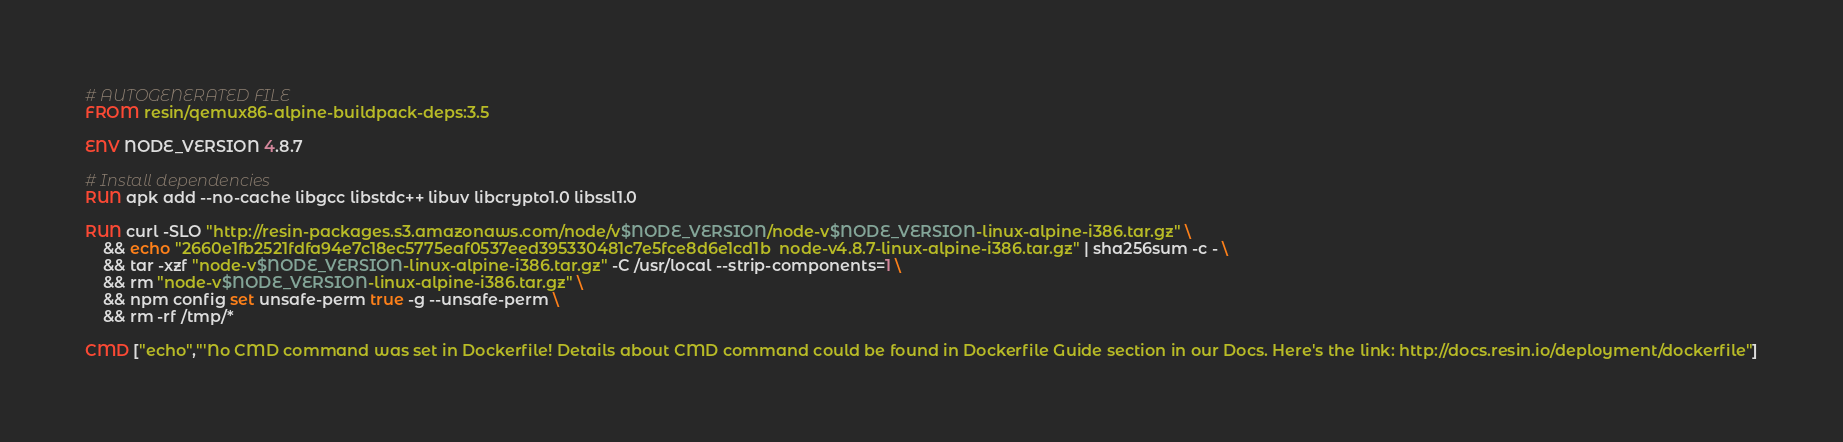<code> <loc_0><loc_0><loc_500><loc_500><_Dockerfile_># AUTOGENERATED FILE
FROM resin/qemux86-alpine-buildpack-deps:3.5

ENV NODE_VERSION 4.8.7

# Install dependencies
RUN apk add --no-cache libgcc libstdc++ libuv libcrypto1.0 libssl1.0

RUN curl -SLO "http://resin-packages.s3.amazonaws.com/node/v$NODE_VERSION/node-v$NODE_VERSION-linux-alpine-i386.tar.gz" \
	&& echo "2660e1fb2521fdfa94e7c18ec5775eaf0537eed395330481c7e5fce8d6e1cd1b  node-v4.8.7-linux-alpine-i386.tar.gz" | sha256sum -c - \
	&& tar -xzf "node-v$NODE_VERSION-linux-alpine-i386.tar.gz" -C /usr/local --strip-components=1 \
	&& rm "node-v$NODE_VERSION-linux-alpine-i386.tar.gz" \
	&& npm config set unsafe-perm true -g --unsafe-perm \
	&& rm -rf /tmp/*

CMD ["echo","'No CMD command was set in Dockerfile! Details about CMD command could be found in Dockerfile Guide section in our Docs. Here's the link: http://docs.resin.io/deployment/dockerfile"]
</code> 